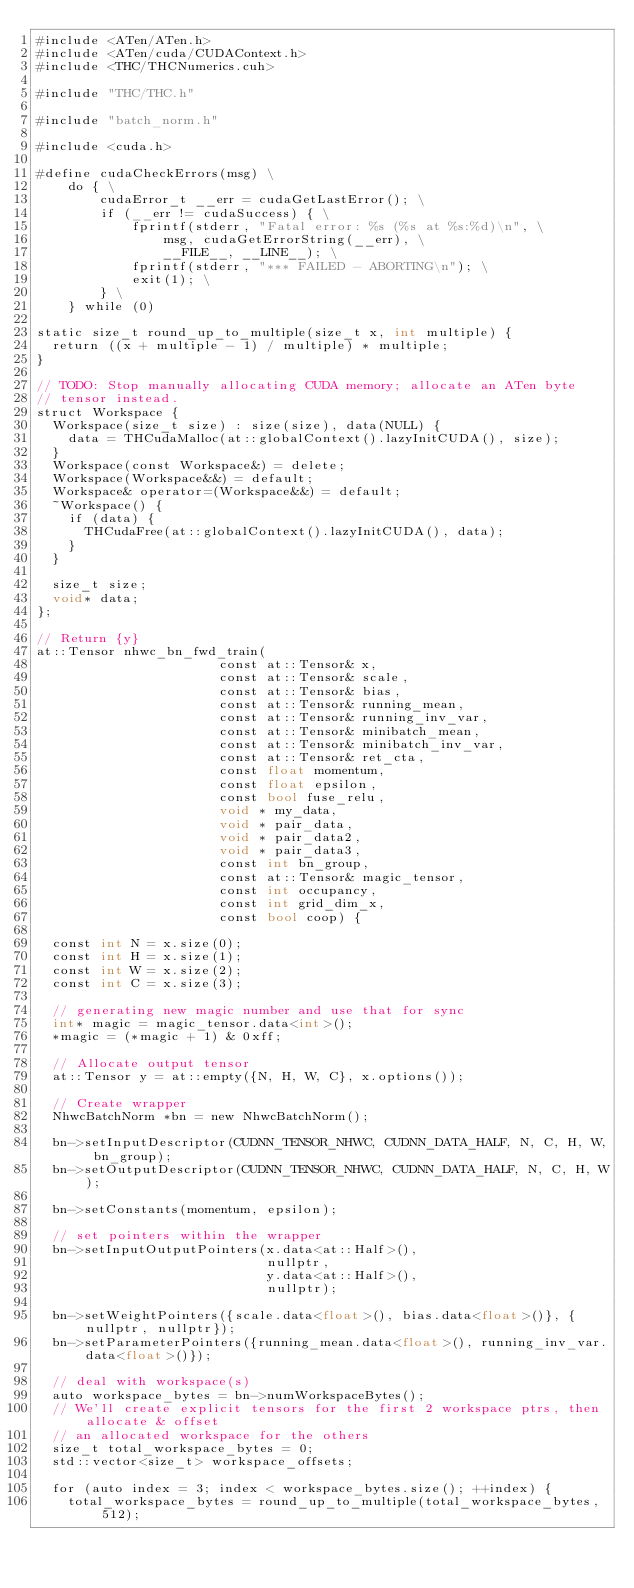Convert code to text. <code><loc_0><loc_0><loc_500><loc_500><_Cuda_>#include <ATen/ATen.h>
#include <ATen/cuda/CUDAContext.h>
#include <THC/THCNumerics.cuh>

#include "THC/THC.h"

#include "batch_norm.h"

#include <cuda.h>

#define cudaCheckErrors(msg) \
    do { \
        cudaError_t __err = cudaGetLastError(); \
        if (__err != cudaSuccess) { \
            fprintf(stderr, "Fatal error: %s (%s at %s:%d)\n", \
                msg, cudaGetErrorString(__err), \
                __FILE__, __LINE__); \
            fprintf(stderr, "*** FAILED - ABORTING\n"); \
            exit(1); \
        } \
    } while (0)

static size_t round_up_to_multiple(size_t x, int multiple) {
  return ((x + multiple - 1) / multiple) * multiple;
}

// TODO: Stop manually allocating CUDA memory; allocate an ATen byte
// tensor instead.
struct Workspace {
  Workspace(size_t size) : size(size), data(NULL) {
    data = THCudaMalloc(at::globalContext().lazyInitCUDA(), size);
  }
  Workspace(const Workspace&) = delete;
  Workspace(Workspace&&) = default;
  Workspace& operator=(Workspace&&) = default;
  ~Workspace() {
    if (data) {
      THCudaFree(at::globalContext().lazyInitCUDA(), data);
    }
  }

  size_t size;
  void* data;
};

// Return {y}
at::Tensor nhwc_bn_fwd_train(
                       const at::Tensor& x,
                       const at::Tensor& scale,
                       const at::Tensor& bias,
                       const at::Tensor& running_mean,
                       const at::Tensor& running_inv_var,
                       const at::Tensor& minibatch_mean,
                       const at::Tensor& minibatch_inv_var,
                       const at::Tensor& ret_cta,
                       const float momentum,
                       const float epsilon,
                       const bool fuse_relu,
                       void * my_data,
                       void * pair_data,
                       void * pair_data2,
                       void * pair_data3,
                       const int bn_group,
                       const at::Tensor& magic_tensor,
                       const int occupancy,
                       const int grid_dim_x,
                       const bool coop) {

  const int N = x.size(0);
  const int H = x.size(1);
  const int W = x.size(2);
  const int C = x.size(3);

  // generating new magic number and use that for sync
  int* magic = magic_tensor.data<int>();
  *magic = (*magic + 1) & 0xff;

  // Allocate output tensor
  at::Tensor y = at::empty({N, H, W, C}, x.options());

  // Create wrapper
  NhwcBatchNorm *bn = new NhwcBatchNorm();

  bn->setInputDescriptor(CUDNN_TENSOR_NHWC, CUDNN_DATA_HALF, N, C, H, W, bn_group);
  bn->setOutputDescriptor(CUDNN_TENSOR_NHWC, CUDNN_DATA_HALF, N, C, H, W);

  bn->setConstants(momentum, epsilon);

  // set pointers within the wrapper
  bn->setInputOutputPointers(x.data<at::Half>(),
                             nullptr,
                             y.data<at::Half>(),
                             nullptr);

  bn->setWeightPointers({scale.data<float>(), bias.data<float>()}, {nullptr, nullptr});
  bn->setParameterPointers({running_mean.data<float>(), running_inv_var.data<float>()});

  // deal with workspace(s)
  auto workspace_bytes = bn->numWorkspaceBytes();
  // We'll create explicit tensors for the first 2 workspace ptrs, then allocate & offset
  // an allocated workspace for the others
  size_t total_workspace_bytes = 0;
  std::vector<size_t> workspace_offsets;

  for (auto index = 3; index < workspace_bytes.size(); ++index) {
    total_workspace_bytes = round_up_to_multiple(total_workspace_bytes, 512);</code> 